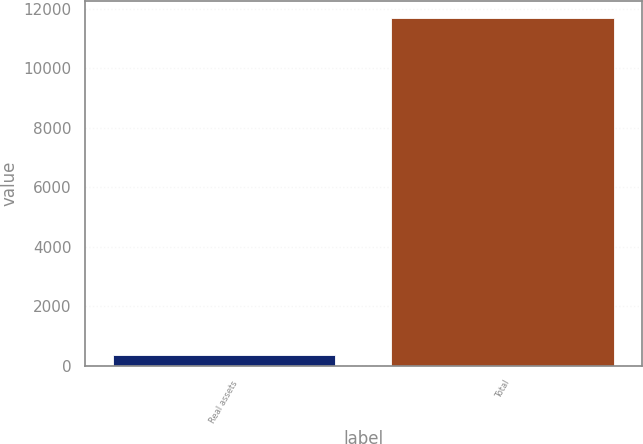<chart> <loc_0><loc_0><loc_500><loc_500><bar_chart><fcel>Real assets<fcel>Total<nl><fcel>351<fcel>11681<nl></chart> 